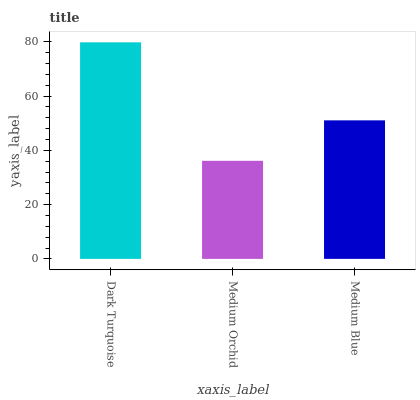Is Medium Blue the minimum?
Answer yes or no. No. Is Medium Blue the maximum?
Answer yes or no. No. Is Medium Blue greater than Medium Orchid?
Answer yes or no. Yes. Is Medium Orchid less than Medium Blue?
Answer yes or no. Yes. Is Medium Orchid greater than Medium Blue?
Answer yes or no. No. Is Medium Blue less than Medium Orchid?
Answer yes or no. No. Is Medium Blue the high median?
Answer yes or no. Yes. Is Medium Blue the low median?
Answer yes or no. Yes. Is Medium Orchid the high median?
Answer yes or no. No. Is Medium Orchid the low median?
Answer yes or no. No. 